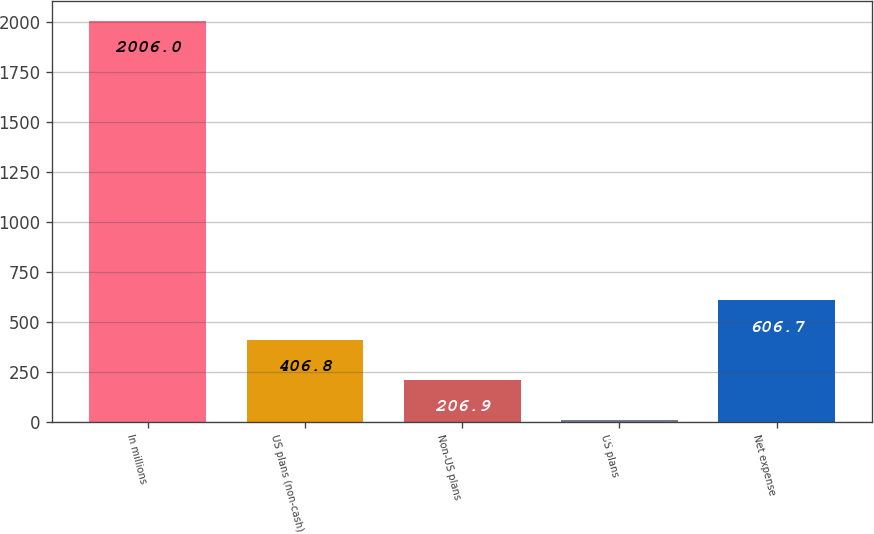<chart> <loc_0><loc_0><loc_500><loc_500><bar_chart><fcel>In millions<fcel>US plans (non-cash)<fcel>Non-US plans<fcel>US plans<fcel>Net expense<nl><fcel>2006<fcel>406.8<fcel>206.9<fcel>7<fcel>606.7<nl></chart> 